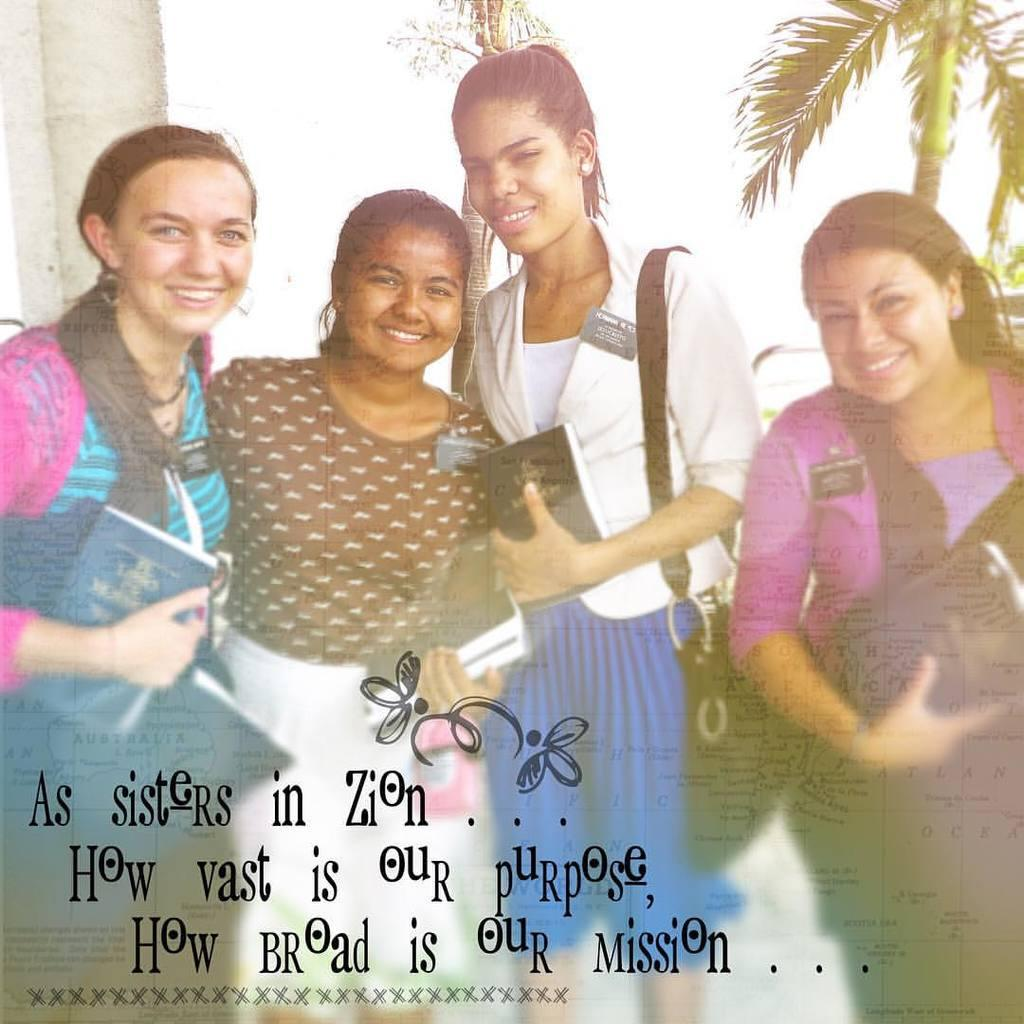What is the main subject of the image? The main subject of the image is the girls in the center. What are the girls holding in their hands? The girls are holding books in their hands. What can be seen in the background of the image? There are trees in the background of the image. What type of plane can be seen flying in the image? There is no plane visible in the image; it only features the girls and trees in the background. 